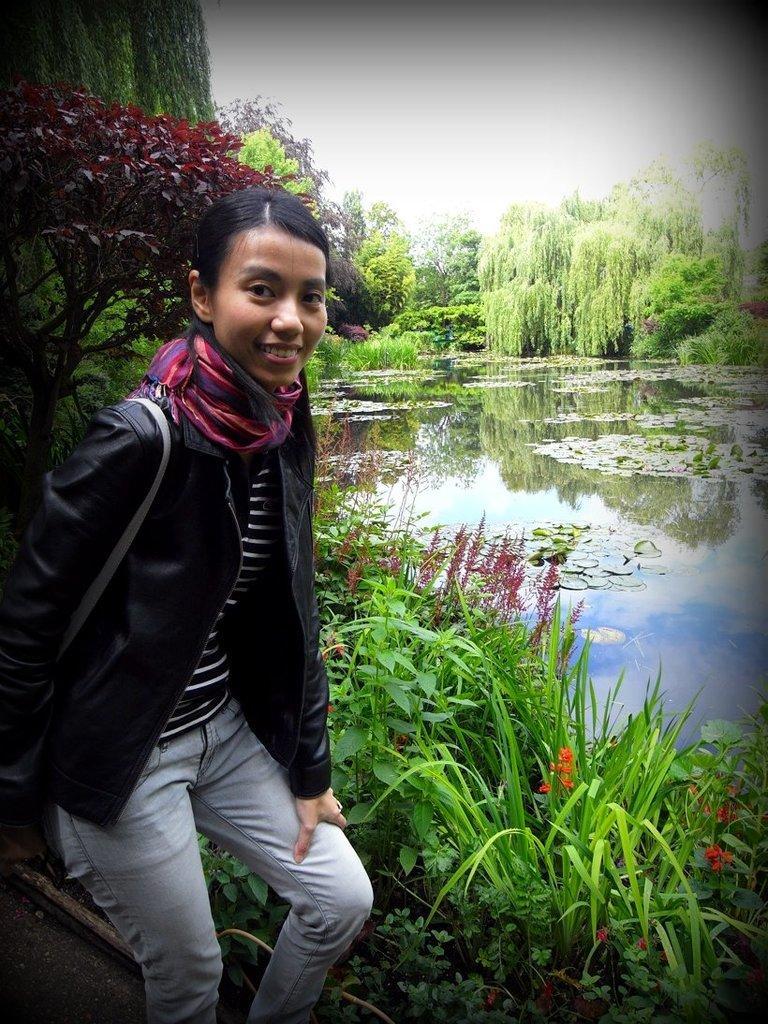Could you give a brief overview of what you see in this image? In this image, we can see a person. We can see some plants, trees. We can see some water with some objects. We can also see the sky and the reflection of trees is seen in the water. 